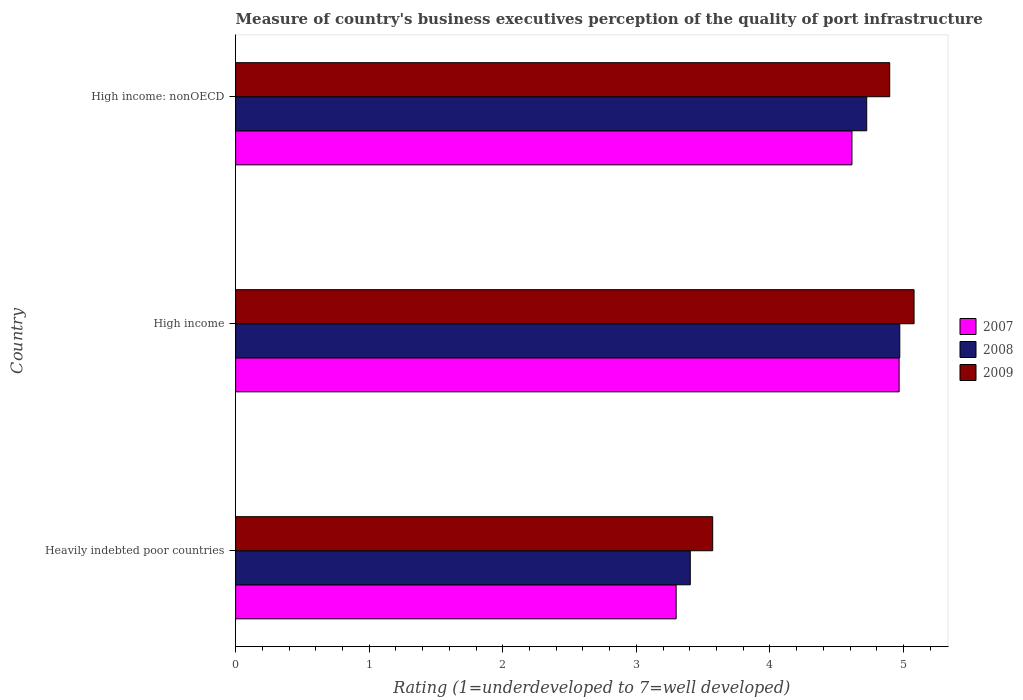Are the number of bars per tick equal to the number of legend labels?
Provide a short and direct response. Yes. What is the label of the 2nd group of bars from the top?
Your answer should be compact. High income. In how many cases, is the number of bars for a given country not equal to the number of legend labels?
Make the answer very short. 0. What is the ratings of the quality of port infrastructure in 2007 in High income: nonOECD?
Offer a very short reply. 4.61. Across all countries, what is the maximum ratings of the quality of port infrastructure in 2009?
Provide a short and direct response. 5.08. Across all countries, what is the minimum ratings of the quality of port infrastructure in 2008?
Ensure brevity in your answer.  3.4. In which country was the ratings of the quality of port infrastructure in 2008 maximum?
Ensure brevity in your answer.  High income. In which country was the ratings of the quality of port infrastructure in 2007 minimum?
Offer a terse response. Heavily indebted poor countries. What is the total ratings of the quality of port infrastructure in 2009 in the graph?
Your response must be concise. 13.55. What is the difference between the ratings of the quality of port infrastructure in 2007 in High income and that in High income: nonOECD?
Offer a terse response. 0.35. What is the difference between the ratings of the quality of port infrastructure in 2009 in High income and the ratings of the quality of port infrastructure in 2007 in High income: nonOECD?
Provide a short and direct response. 0.46. What is the average ratings of the quality of port infrastructure in 2008 per country?
Offer a very short reply. 4.37. What is the difference between the ratings of the quality of port infrastructure in 2007 and ratings of the quality of port infrastructure in 2009 in Heavily indebted poor countries?
Keep it short and to the point. -0.27. What is the ratio of the ratings of the quality of port infrastructure in 2008 in Heavily indebted poor countries to that in High income?
Make the answer very short. 0.68. Is the ratings of the quality of port infrastructure in 2007 in Heavily indebted poor countries less than that in High income?
Your response must be concise. Yes. What is the difference between the highest and the second highest ratings of the quality of port infrastructure in 2009?
Your answer should be very brief. 0.18. What is the difference between the highest and the lowest ratings of the quality of port infrastructure in 2009?
Your answer should be very brief. 1.51. In how many countries, is the ratings of the quality of port infrastructure in 2007 greater than the average ratings of the quality of port infrastructure in 2007 taken over all countries?
Offer a very short reply. 2. Is the sum of the ratings of the quality of port infrastructure in 2009 in Heavily indebted poor countries and High income greater than the maximum ratings of the quality of port infrastructure in 2008 across all countries?
Give a very brief answer. Yes. How many countries are there in the graph?
Your answer should be compact. 3. What is the difference between two consecutive major ticks on the X-axis?
Your answer should be compact. 1. Are the values on the major ticks of X-axis written in scientific E-notation?
Give a very brief answer. No. Does the graph contain any zero values?
Your answer should be compact. No. Does the graph contain grids?
Your answer should be compact. No. Where does the legend appear in the graph?
Your answer should be compact. Center right. How are the legend labels stacked?
Your answer should be very brief. Vertical. What is the title of the graph?
Make the answer very short. Measure of country's business executives perception of the quality of port infrastructure. What is the label or title of the X-axis?
Provide a short and direct response. Rating (1=underdeveloped to 7=well developed). What is the Rating (1=underdeveloped to 7=well developed) in 2007 in Heavily indebted poor countries?
Provide a short and direct response. 3.3. What is the Rating (1=underdeveloped to 7=well developed) in 2008 in Heavily indebted poor countries?
Your answer should be very brief. 3.4. What is the Rating (1=underdeveloped to 7=well developed) in 2009 in Heavily indebted poor countries?
Offer a very short reply. 3.57. What is the Rating (1=underdeveloped to 7=well developed) in 2007 in High income?
Provide a succinct answer. 4.97. What is the Rating (1=underdeveloped to 7=well developed) of 2008 in High income?
Keep it short and to the point. 4.97. What is the Rating (1=underdeveloped to 7=well developed) of 2009 in High income?
Your answer should be compact. 5.08. What is the Rating (1=underdeveloped to 7=well developed) in 2007 in High income: nonOECD?
Offer a terse response. 4.61. What is the Rating (1=underdeveloped to 7=well developed) in 2008 in High income: nonOECD?
Provide a short and direct response. 4.72. What is the Rating (1=underdeveloped to 7=well developed) of 2009 in High income: nonOECD?
Keep it short and to the point. 4.9. Across all countries, what is the maximum Rating (1=underdeveloped to 7=well developed) in 2007?
Your response must be concise. 4.97. Across all countries, what is the maximum Rating (1=underdeveloped to 7=well developed) in 2008?
Keep it short and to the point. 4.97. Across all countries, what is the maximum Rating (1=underdeveloped to 7=well developed) of 2009?
Keep it short and to the point. 5.08. Across all countries, what is the minimum Rating (1=underdeveloped to 7=well developed) in 2007?
Provide a short and direct response. 3.3. Across all countries, what is the minimum Rating (1=underdeveloped to 7=well developed) in 2008?
Provide a short and direct response. 3.4. Across all countries, what is the minimum Rating (1=underdeveloped to 7=well developed) of 2009?
Offer a very short reply. 3.57. What is the total Rating (1=underdeveloped to 7=well developed) of 2007 in the graph?
Keep it short and to the point. 12.88. What is the total Rating (1=underdeveloped to 7=well developed) of 2008 in the graph?
Keep it short and to the point. 13.1. What is the total Rating (1=underdeveloped to 7=well developed) in 2009 in the graph?
Offer a very short reply. 13.55. What is the difference between the Rating (1=underdeveloped to 7=well developed) of 2007 in Heavily indebted poor countries and that in High income?
Your answer should be compact. -1.67. What is the difference between the Rating (1=underdeveloped to 7=well developed) of 2008 in Heavily indebted poor countries and that in High income?
Provide a short and direct response. -1.57. What is the difference between the Rating (1=underdeveloped to 7=well developed) of 2009 in Heavily indebted poor countries and that in High income?
Provide a succinct answer. -1.51. What is the difference between the Rating (1=underdeveloped to 7=well developed) in 2007 in Heavily indebted poor countries and that in High income: nonOECD?
Provide a short and direct response. -1.32. What is the difference between the Rating (1=underdeveloped to 7=well developed) of 2008 in Heavily indebted poor countries and that in High income: nonOECD?
Give a very brief answer. -1.32. What is the difference between the Rating (1=underdeveloped to 7=well developed) in 2009 in Heavily indebted poor countries and that in High income: nonOECD?
Give a very brief answer. -1.33. What is the difference between the Rating (1=underdeveloped to 7=well developed) of 2007 in High income and that in High income: nonOECD?
Give a very brief answer. 0.35. What is the difference between the Rating (1=underdeveloped to 7=well developed) of 2008 in High income and that in High income: nonOECD?
Offer a very short reply. 0.25. What is the difference between the Rating (1=underdeveloped to 7=well developed) of 2009 in High income and that in High income: nonOECD?
Make the answer very short. 0.18. What is the difference between the Rating (1=underdeveloped to 7=well developed) in 2007 in Heavily indebted poor countries and the Rating (1=underdeveloped to 7=well developed) in 2008 in High income?
Make the answer very short. -1.67. What is the difference between the Rating (1=underdeveloped to 7=well developed) in 2007 in Heavily indebted poor countries and the Rating (1=underdeveloped to 7=well developed) in 2009 in High income?
Your answer should be very brief. -1.78. What is the difference between the Rating (1=underdeveloped to 7=well developed) of 2008 in Heavily indebted poor countries and the Rating (1=underdeveloped to 7=well developed) of 2009 in High income?
Keep it short and to the point. -1.68. What is the difference between the Rating (1=underdeveloped to 7=well developed) of 2007 in Heavily indebted poor countries and the Rating (1=underdeveloped to 7=well developed) of 2008 in High income: nonOECD?
Your response must be concise. -1.43. What is the difference between the Rating (1=underdeveloped to 7=well developed) in 2007 in Heavily indebted poor countries and the Rating (1=underdeveloped to 7=well developed) in 2009 in High income: nonOECD?
Give a very brief answer. -1.6. What is the difference between the Rating (1=underdeveloped to 7=well developed) in 2008 in Heavily indebted poor countries and the Rating (1=underdeveloped to 7=well developed) in 2009 in High income: nonOECD?
Your response must be concise. -1.49. What is the difference between the Rating (1=underdeveloped to 7=well developed) in 2007 in High income and the Rating (1=underdeveloped to 7=well developed) in 2008 in High income: nonOECD?
Your answer should be very brief. 0.24. What is the difference between the Rating (1=underdeveloped to 7=well developed) of 2007 in High income and the Rating (1=underdeveloped to 7=well developed) of 2009 in High income: nonOECD?
Ensure brevity in your answer.  0.07. What is the difference between the Rating (1=underdeveloped to 7=well developed) of 2008 in High income and the Rating (1=underdeveloped to 7=well developed) of 2009 in High income: nonOECD?
Your answer should be very brief. 0.08. What is the average Rating (1=underdeveloped to 7=well developed) in 2007 per country?
Provide a short and direct response. 4.29. What is the average Rating (1=underdeveloped to 7=well developed) of 2008 per country?
Give a very brief answer. 4.37. What is the average Rating (1=underdeveloped to 7=well developed) of 2009 per country?
Your answer should be very brief. 4.52. What is the difference between the Rating (1=underdeveloped to 7=well developed) in 2007 and Rating (1=underdeveloped to 7=well developed) in 2008 in Heavily indebted poor countries?
Offer a very short reply. -0.11. What is the difference between the Rating (1=underdeveloped to 7=well developed) in 2007 and Rating (1=underdeveloped to 7=well developed) in 2009 in Heavily indebted poor countries?
Make the answer very short. -0.27. What is the difference between the Rating (1=underdeveloped to 7=well developed) in 2008 and Rating (1=underdeveloped to 7=well developed) in 2009 in Heavily indebted poor countries?
Your response must be concise. -0.17. What is the difference between the Rating (1=underdeveloped to 7=well developed) in 2007 and Rating (1=underdeveloped to 7=well developed) in 2008 in High income?
Make the answer very short. -0.01. What is the difference between the Rating (1=underdeveloped to 7=well developed) in 2007 and Rating (1=underdeveloped to 7=well developed) in 2009 in High income?
Your answer should be very brief. -0.11. What is the difference between the Rating (1=underdeveloped to 7=well developed) in 2008 and Rating (1=underdeveloped to 7=well developed) in 2009 in High income?
Your answer should be compact. -0.11. What is the difference between the Rating (1=underdeveloped to 7=well developed) of 2007 and Rating (1=underdeveloped to 7=well developed) of 2008 in High income: nonOECD?
Give a very brief answer. -0.11. What is the difference between the Rating (1=underdeveloped to 7=well developed) in 2007 and Rating (1=underdeveloped to 7=well developed) in 2009 in High income: nonOECD?
Your answer should be very brief. -0.28. What is the difference between the Rating (1=underdeveloped to 7=well developed) of 2008 and Rating (1=underdeveloped to 7=well developed) of 2009 in High income: nonOECD?
Ensure brevity in your answer.  -0.17. What is the ratio of the Rating (1=underdeveloped to 7=well developed) in 2007 in Heavily indebted poor countries to that in High income?
Your answer should be very brief. 0.66. What is the ratio of the Rating (1=underdeveloped to 7=well developed) in 2008 in Heavily indebted poor countries to that in High income?
Provide a short and direct response. 0.68. What is the ratio of the Rating (1=underdeveloped to 7=well developed) of 2009 in Heavily indebted poor countries to that in High income?
Your answer should be compact. 0.7. What is the ratio of the Rating (1=underdeveloped to 7=well developed) in 2007 in Heavily indebted poor countries to that in High income: nonOECD?
Ensure brevity in your answer.  0.71. What is the ratio of the Rating (1=underdeveloped to 7=well developed) of 2008 in Heavily indebted poor countries to that in High income: nonOECD?
Offer a very short reply. 0.72. What is the ratio of the Rating (1=underdeveloped to 7=well developed) in 2009 in Heavily indebted poor countries to that in High income: nonOECD?
Offer a terse response. 0.73. What is the ratio of the Rating (1=underdeveloped to 7=well developed) of 2007 in High income to that in High income: nonOECD?
Offer a terse response. 1.08. What is the ratio of the Rating (1=underdeveloped to 7=well developed) of 2008 in High income to that in High income: nonOECD?
Your response must be concise. 1.05. What is the ratio of the Rating (1=underdeveloped to 7=well developed) of 2009 in High income to that in High income: nonOECD?
Provide a short and direct response. 1.04. What is the difference between the highest and the second highest Rating (1=underdeveloped to 7=well developed) of 2007?
Offer a terse response. 0.35. What is the difference between the highest and the second highest Rating (1=underdeveloped to 7=well developed) of 2008?
Keep it short and to the point. 0.25. What is the difference between the highest and the second highest Rating (1=underdeveloped to 7=well developed) of 2009?
Provide a succinct answer. 0.18. What is the difference between the highest and the lowest Rating (1=underdeveloped to 7=well developed) in 2007?
Make the answer very short. 1.67. What is the difference between the highest and the lowest Rating (1=underdeveloped to 7=well developed) in 2008?
Make the answer very short. 1.57. What is the difference between the highest and the lowest Rating (1=underdeveloped to 7=well developed) in 2009?
Provide a succinct answer. 1.51. 